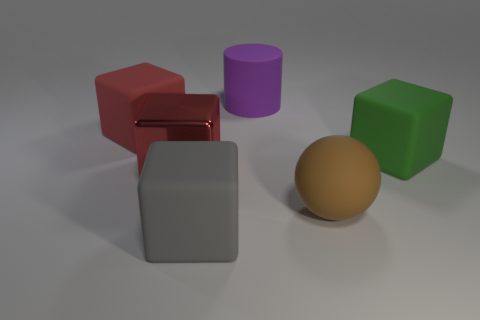Can you describe the colors and shapes of the objects in the image? Certainly! In the image, there are five objects with distinct colors and shapes. Starting from the left, there is a red cube with a reflective surface, followed by a medium grey matte cube. Towards the center, there is a purple cylinder with a matte finish, and next to it, a yellow sphere with a muted sheen. Lastly, on the far right, there is a green cube with a matte surface.  How are the shadows cast by the objects, and what does that tell us about the light source? The shadows extend towards the left of the objects, indicating that the primary light source is on the right, out of the image frame. The shadows are soft-edged, suggesting that the light source is not overly harsh and that there might be some diffusion involved, either from the light itself or due to the environment around the objects. 